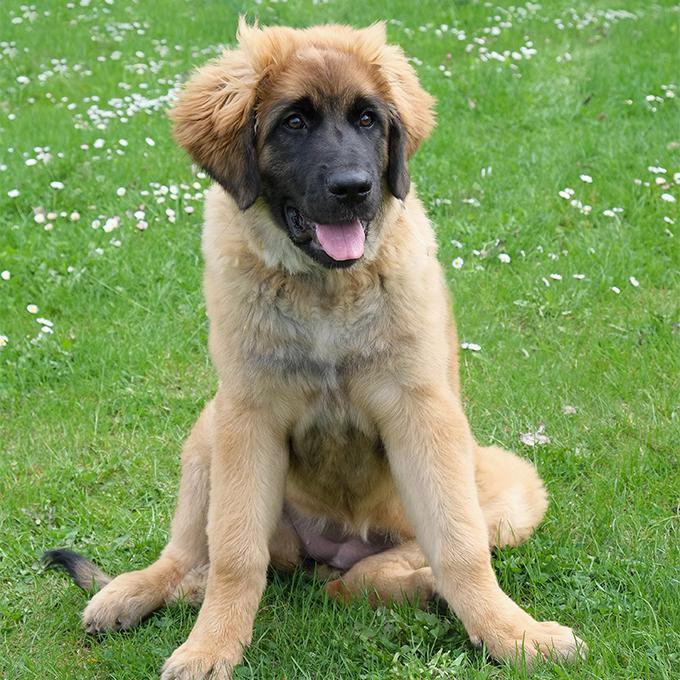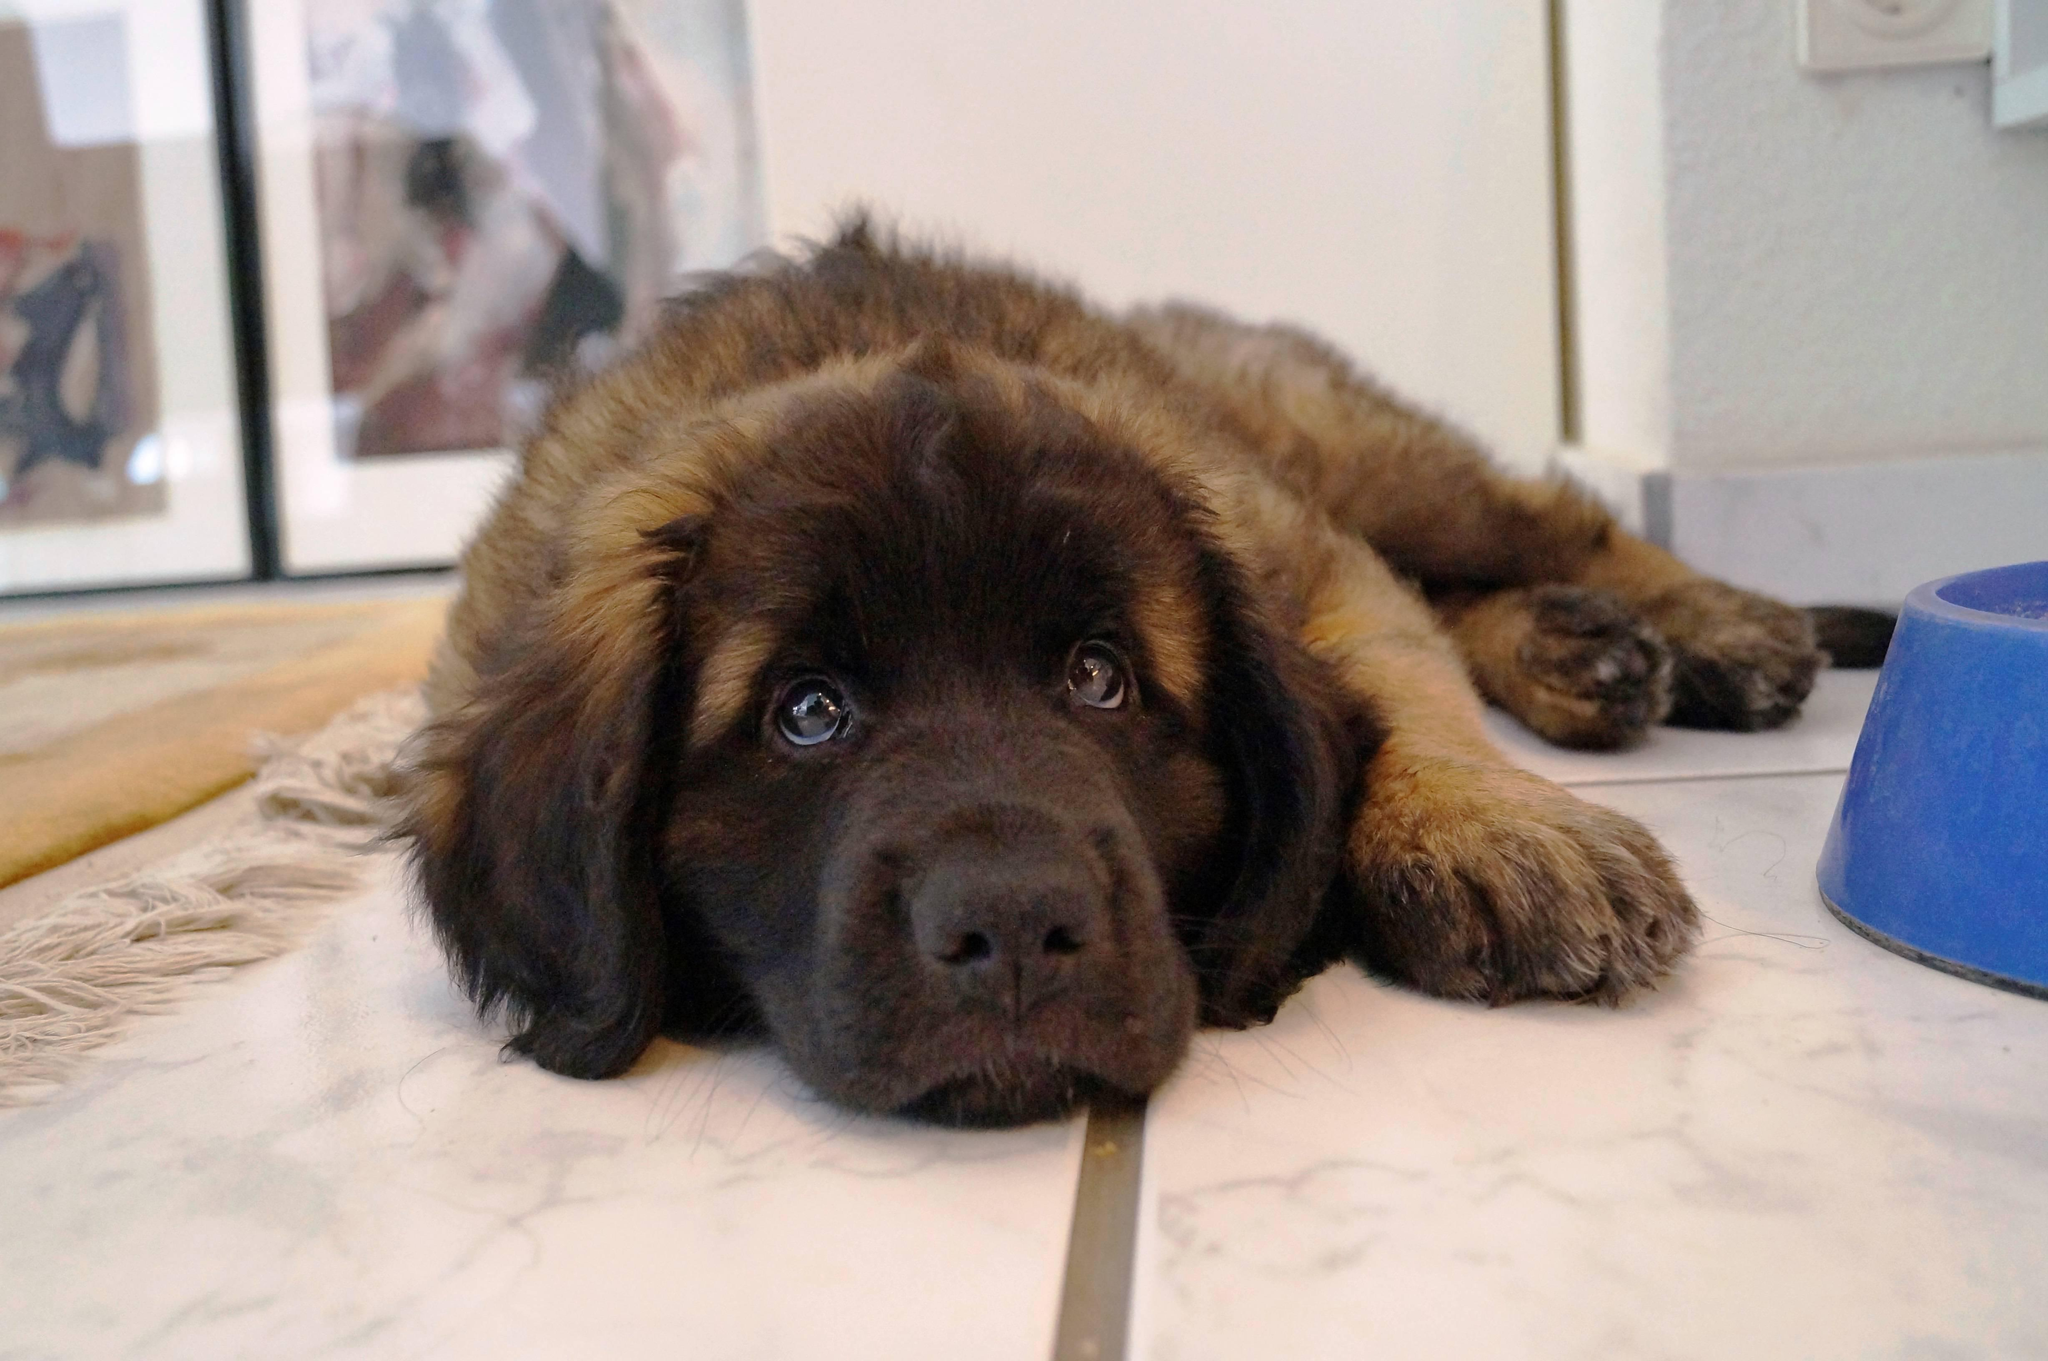The first image is the image on the left, the second image is the image on the right. Given the left and right images, does the statement "One of the dogs is laying down with its head on the floor." hold true? Answer yes or no. Yes. The first image is the image on the left, the second image is the image on the right. For the images shown, is this caption "A dog is looking to the left" true? Answer yes or no. No. 